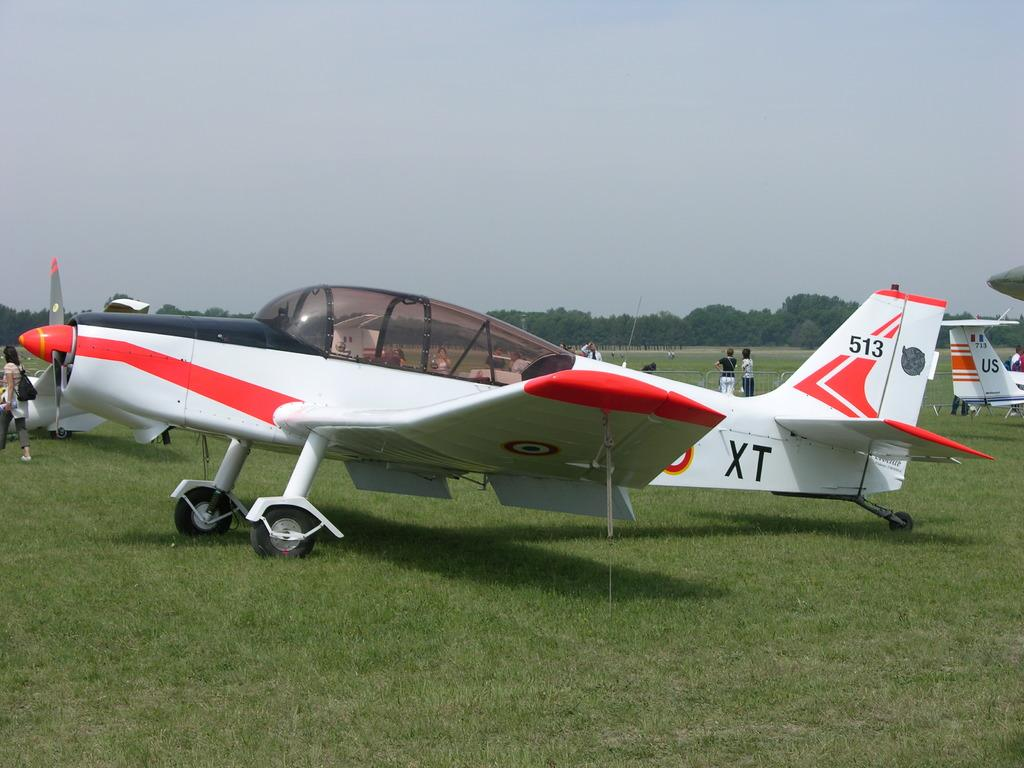<image>
Give a short and clear explanation of the subsequent image. An XT plane is parked in a field of grass. 